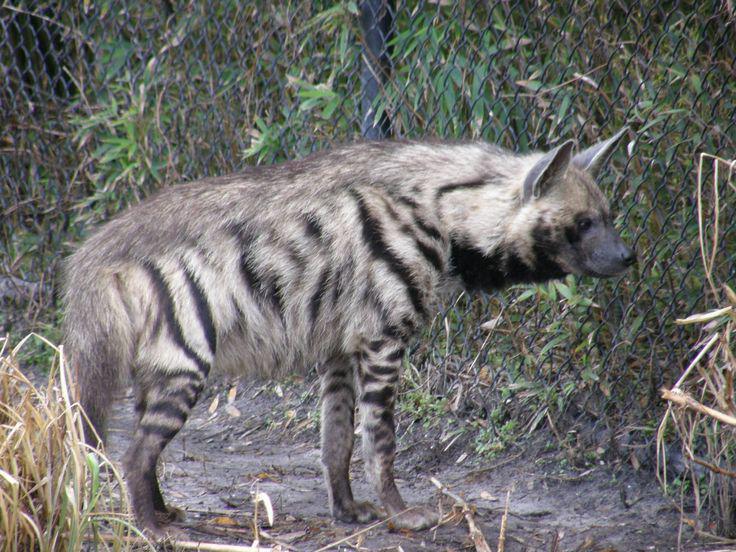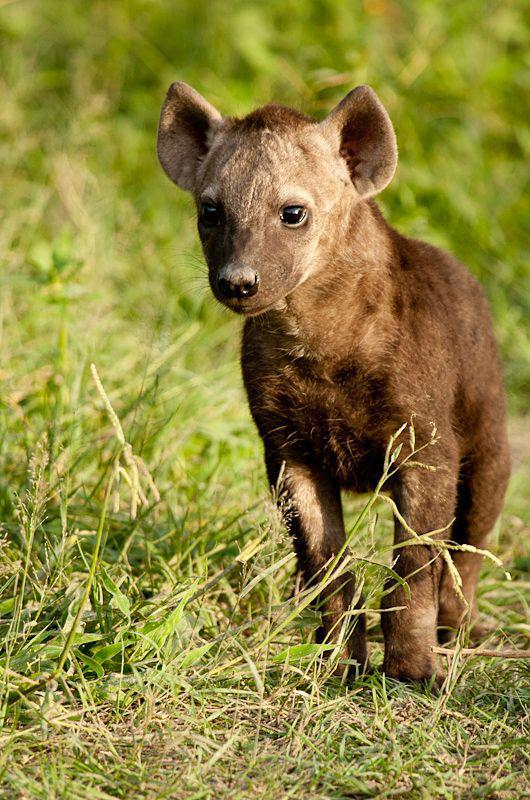The first image is the image on the left, the second image is the image on the right. Assess this claim about the two images: "No image contains more than one animal, and one image features an adult hyena in a standing pose with its body turned rightward.". Correct or not? Answer yes or no. Yes. The first image is the image on the left, the second image is the image on the right. Given the left and right images, does the statement "At least one hyena is laying down." hold true? Answer yes or no. No. 